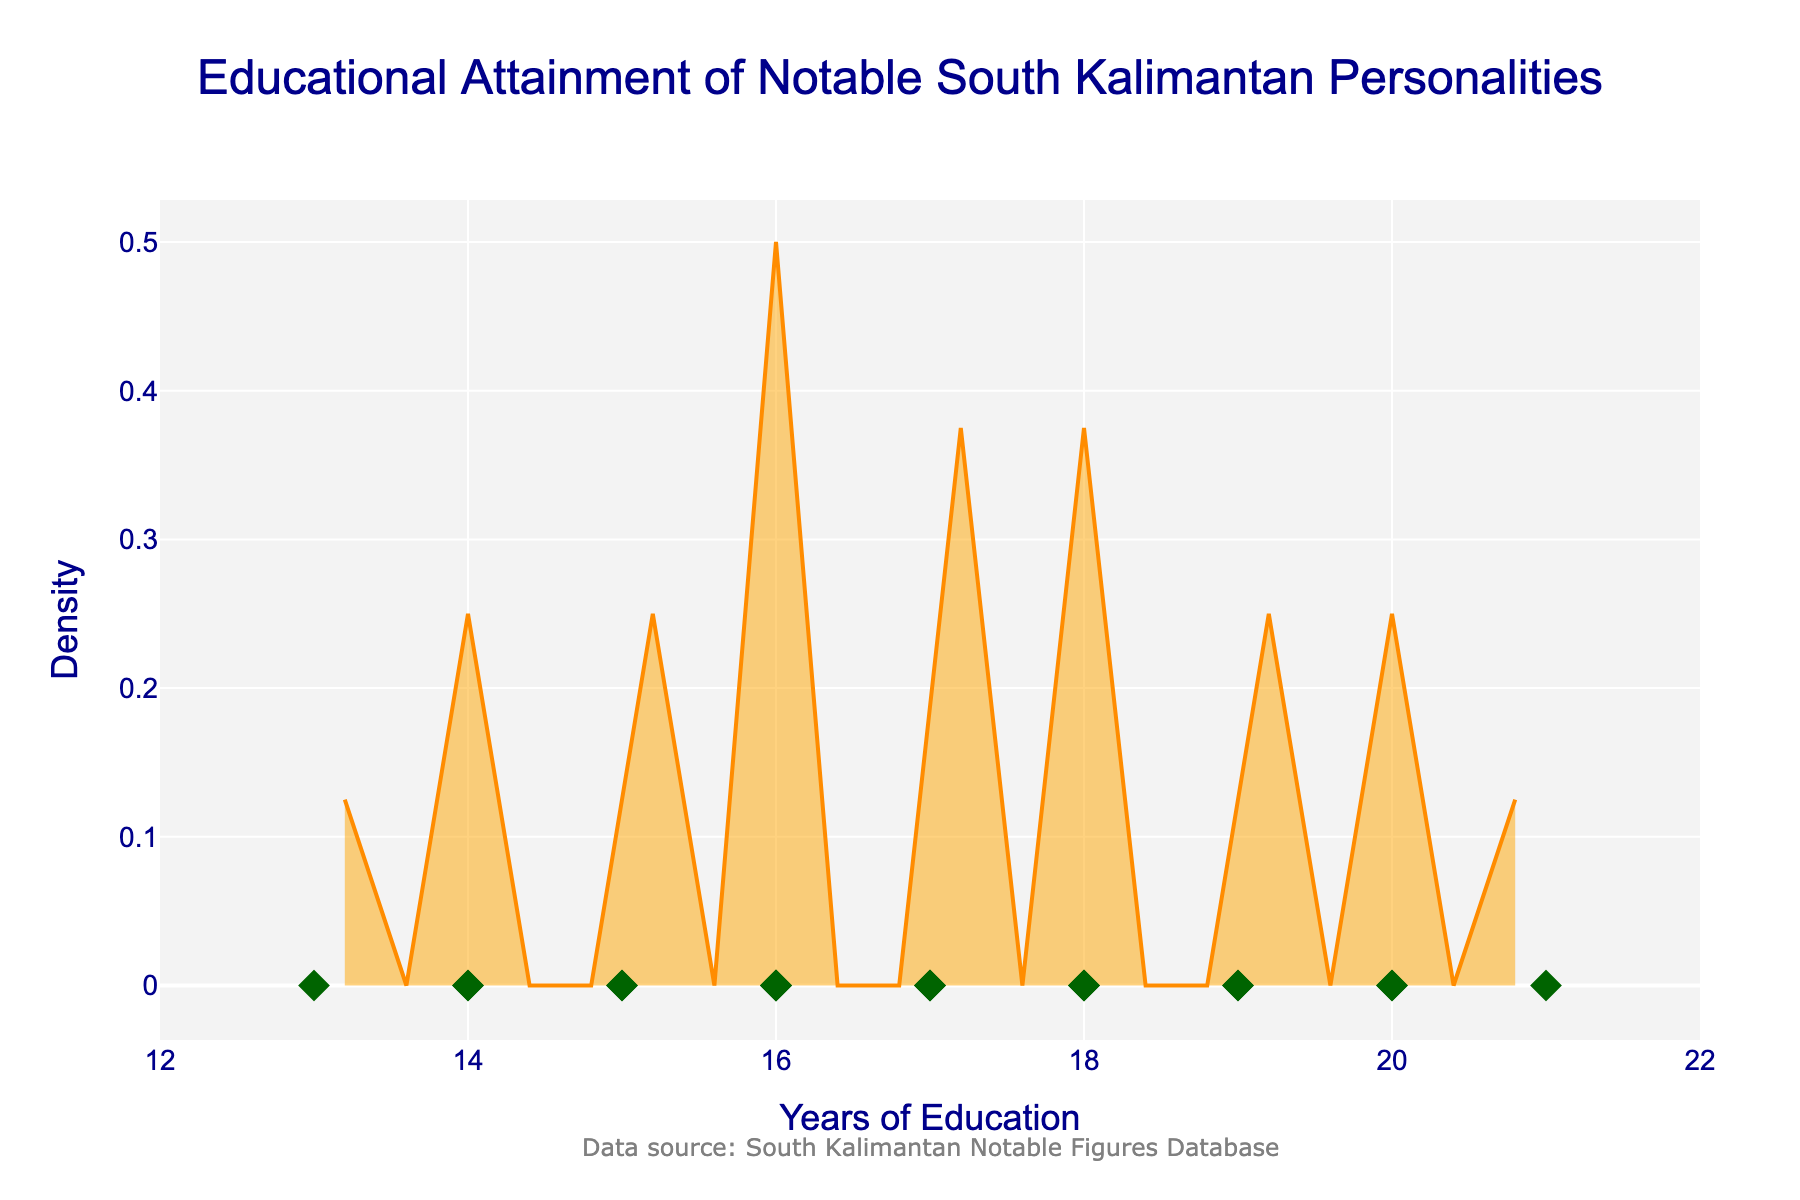What does the title of the plot say? The title is located at the top of the plot and is one of the most prominent pieces of text. It reads: 'Educational Attainment of Notable South Kalimantan Personalities'.
Answer: Educational Attainment of Notable South Kalimantan Personalities What do the x-axis and y-axis represent? The x-axis is labeled 'Years of Education' and the y-axis is labeled 'Density'. This means the x-axis shows the number of years of education, and the y-axis shows the density of data points at those education levels.
Answer: x-axis: Years of Education, y-axis: Density How many individual data points are shown in the plot? Each individual data point is represented as a diamond-shaped marker along the x-axis. There are 20 names listed in the data, so there are 20 diamond markers in the plot.
Answer: 20 Which education level has the highest density of notable figures? The highest peak in the density plot indicates the education level with the highest density of notable figures. The peak occurs approximately at the education level of 16 years.
Answer: 16 years What is the range of education levels shown in the plot? The x-axis represents the education levels, and it ranges from 12 to 22 years of education as indicated by the x-axis labels.
Answer: 12 to 22 years How many notable figures have an education level higher than 18 years? The individual data points (diamond markers) can be inspected to see which ones have x-values greater than 18. There are four markers: Idham Chalid (20), Zainuddin Hasan (19), Khairil Anwar (20), and Syarifuddin Yoes (21).
Answer: 4 Which education levels have more than three notable figures? To find the education levels with more than three notable figures, we look at where the density plot has significant peaks. The peaks around 16, 17, and 18 years have the highest densities, each likely with more than three notable figures.
Answer: 16, 17, 18 years What is the median education level of the notable figures? The median education level is the middle value when the education levels are ordered. The data points arranged in ascending order are 13, 14, 14, 15, 15, 16, 16, 16, 16, 17, 17, 17, 18, 18, 18, 19, 19, 20, 20, 21. The median value, which is the 10th and 11th value average, is 17.
Answer: 17 years Is there a noticeable trend or pattern in the educational attainment of these figures? The density plot shows a higher concentration of notable figures around 16 to 18 years of education. This could suggest a trend where these individuals typically have about 16-18 years of education.
Answer: Higher concentration around 16-18 years What colors are used in the plot for the density line and the individual data points? The density line is a dark orange color, and individual data points are represented by dark green diamond markers.
Answer: Dark orange (density line), dark green (data points) 